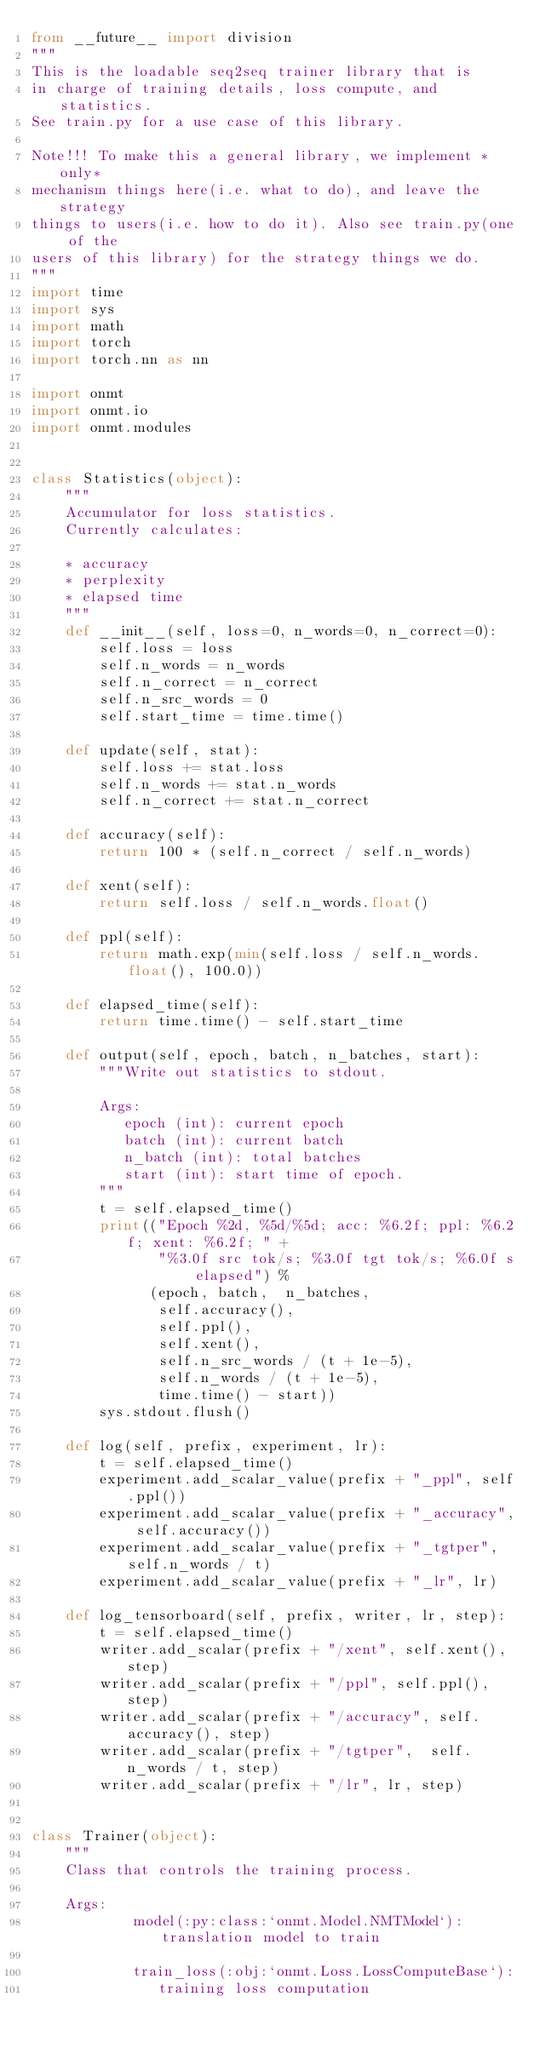Convert code to text. <code><loc_0><loc_0><loc_500><loc_500><_Python_>from __future__ import division
"""
This is the loadable seq2seq trainer library that is
in charge of training details, loss compute, and statistics.
See train.py for a use case of this library.

Note!!! To make this a general library, we implement *only*
mechanism things here(i.e. what to do), and leave the strategy
things to users(i.e. how to do it). Also see train.py(one of the
users of this library) for the strategy things we do.
"""
import time
import sys
import math
import torch
import torch.nn as nn

import onmt
import onmt.io
import onmt.modules


class Statistics(object):
    """
    Accumulator for loss statistics.
    Currently calculates:

    * accuracy
    * perplexity
    * elapsed time
    """
    def __init__(self, loss=0, n_words=0, n_correct=0):
        self.loss = loss
        self.n_words = n_words
        self.n_correct = n_correct
        self.n_src_words = 0
        self.start_time = time.time()

    def update(self, stat):
        self.loss += stat.loss
        self.n_words += stat.n_words
        self.n_correct += stat.n_correct

    def accuracy(self):
        return 100 * (self.n_correct / self.n_words)

    def xent(self):
        return self.loss / self.n_words.float()

    def ppl(self):
        return math.exp(min(self.loss / self.n_words.float(), 100.0))

    def elapsed_time(self):
        return time.time() - self.start_time

    def output(self, epoch, batch, n_batches, start):
        """Write out statistics to stdout.

        Args:
           epoch (int): current epoch
           batch (int): current batch
           n_batch (int): total batches
           start (int): start time of epoch.
        """
        t = self.elapsed_time()
        print(("Epoch %2d, %5d/%5d; acc: %6.2f; ppl: %6.2f; xent: %6.2f; " +
               "%3.0f src tok/s; %3.0f tgt tok/s; %6.0f s elapsed") %
              (epoch, batch,  n_batches,
               self.accuracy(),
               self.ppl(),
               self.xent(),
               self.n_src_words / (t + 1e-5),
               self.n_words / (t + 1e-5),
               time.time() - start))
        sys.stdout.flush()

    def log(self, prefix, experiment, lr):
        t = self.elapsed_time()
        experiment.add_scalar_value(prefix + "_ppl", self.ppl())
        experiment.add_scalar_value(prefix + "_accuracy", self.accuracy())
        experiment.add_scalar_value(prefix + "_tgtper",  self.n_words / t)
        experiment.add_scalar_value(prefix + "_lr", lr)

    def log_tensorboard(self, prefix, writer, lr, step):
        t = self.elapsed_time()
        writer.add_scalar(prefix + "/xent", self.xent(), step)
        writer.add_scalar(prefix + "/ppl", self.ppl(), step)
        writer.add_scalar(prefix + "/accuracy", self.accuracy(), step)
        writer.add_scalar(prefix + "/tgtper",  self.n_words / t, step)
        writer.add_scalar(prefix + "/lr", lr, step)


class Trainer(object):
    """
    Class that controls the training process.

    Args:
            model(:py:class:`onmt.Model.NMTModel`): translation model to train

            train_loss(:obj:`onmt.Loss.LossComputeBase`):
               training loss computation</code> 